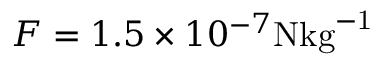<formula> <loc_0><loc_0><loc_500><loc_500>F = 1 . 5 \times 1 0 ^ { - 7 } N { k g } ^ { - 1 }</formula> 